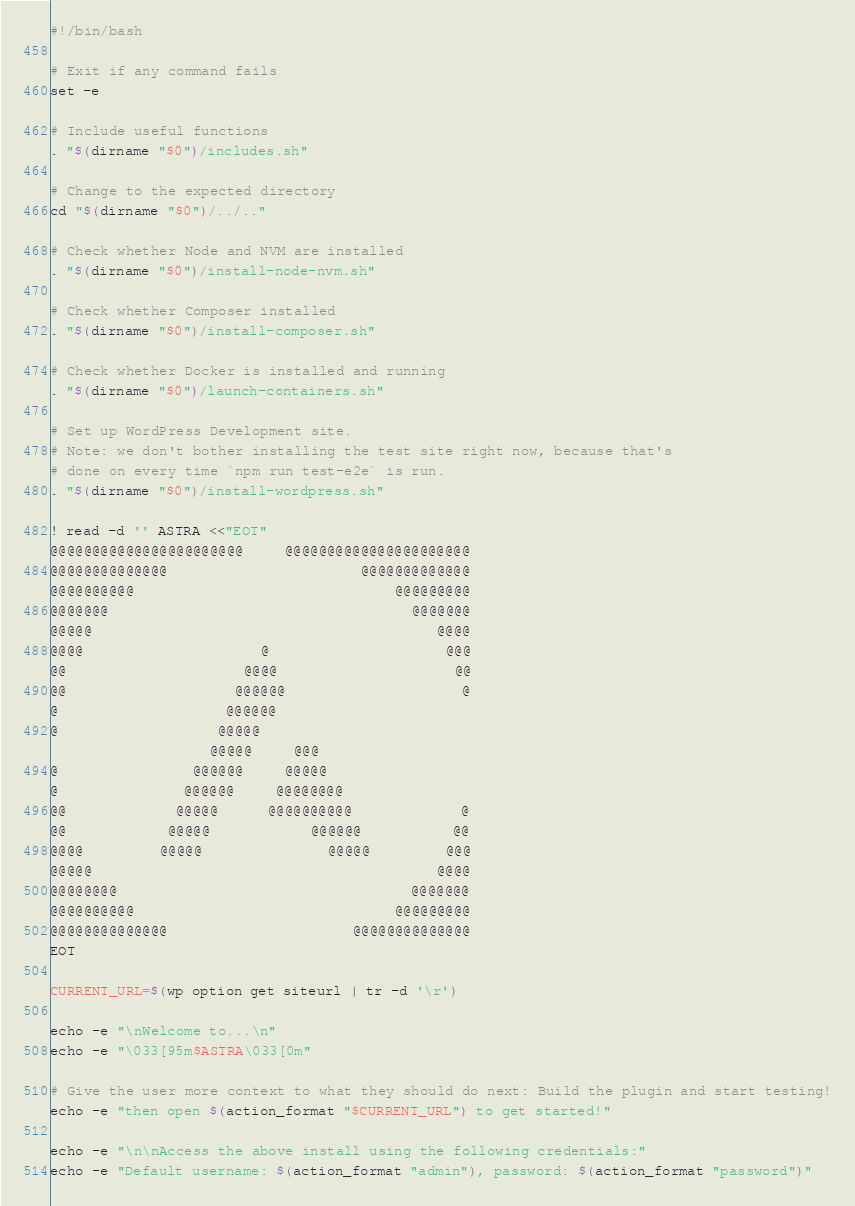<code> <loc_0><loc_0><loc_500><loc_500><_Bash_>#!/bin/bash

# Exit if any command fails
set -e

# Include useful functions
. "$(dirname "$0")/includes.sh"

# Change to the expected directory
cd "$(dirname "$0")/../.."

# Check whether Node and NVM are installed
. "$(dirname "$0")/install-node-nvm.sh"

# Check whether Composer installed
. "$(dirname "$0")/install-composer.sh"

# Check whether Docker is installed and running
. "$(dirname "$0")/launch-containers.sh"

# Set up WordPress Development site.
# Note: we don't bother installing the test site right now, because that's
# done on every time `npm run test-e2e` is run.
. "$(dirname "$0")/install-wordpress.sh"

! read -d '' ASTRA <<"EOT"
@@@@@@@@@@@@@@@@@@@@@@@     @@@@@@@@@@@@@@@@@@@@@@
@@@@@@@@@@@@@@                       @@@@@@@@@@@@@
@@@@@@@@@@                               @@@@@@@@@
@@@@@@@                                    @@@@@@@
@@@@@                                         @@@@
@@@@                     @                     @@@
@@                     @@@@                     @@
@@                    @@@@@@                     @
@                    @@@@@@
@                   @@@@@
                   @@@@@     @@@
@                @@@@@@     @@@@@
@               @@@@@@     @@@@@@@@
@@             @@@@@      @@@@@@@@@@             @
@@            @@@@@            @@@@@@           @@
@@@@         @@@@@               @@@@@         @@@
@@@@@                                         @@@@
@@@@@@@@                                   @@@@@@@
@@@@@@@@@@                               @@@@@@@@@
@@@@@@@@@@@@@@                      @@@@@@@@@@@@@@
EOT

CURRENT_URL=$(wp option get siteurl | tr -d '\r')

echo -e "\nWelcome to...\n"
echo -e "\033[95m$ASTRA\033[0m"

# Give the user more context to what they should do next: Build the plugin and start testing!
echo -e "then open $(action_format "$CURRENT_URL") to get started!"

echo -e "\n\nAccess the above install using the following credentials:"
echo -e "Default username: $(action_format "admin"), password: $(action_format "password")"
</code> 